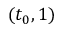<formula> <loc_0><loc_0><loc_500><loc_500>( t _ { 0 } , 1 )</formula> 